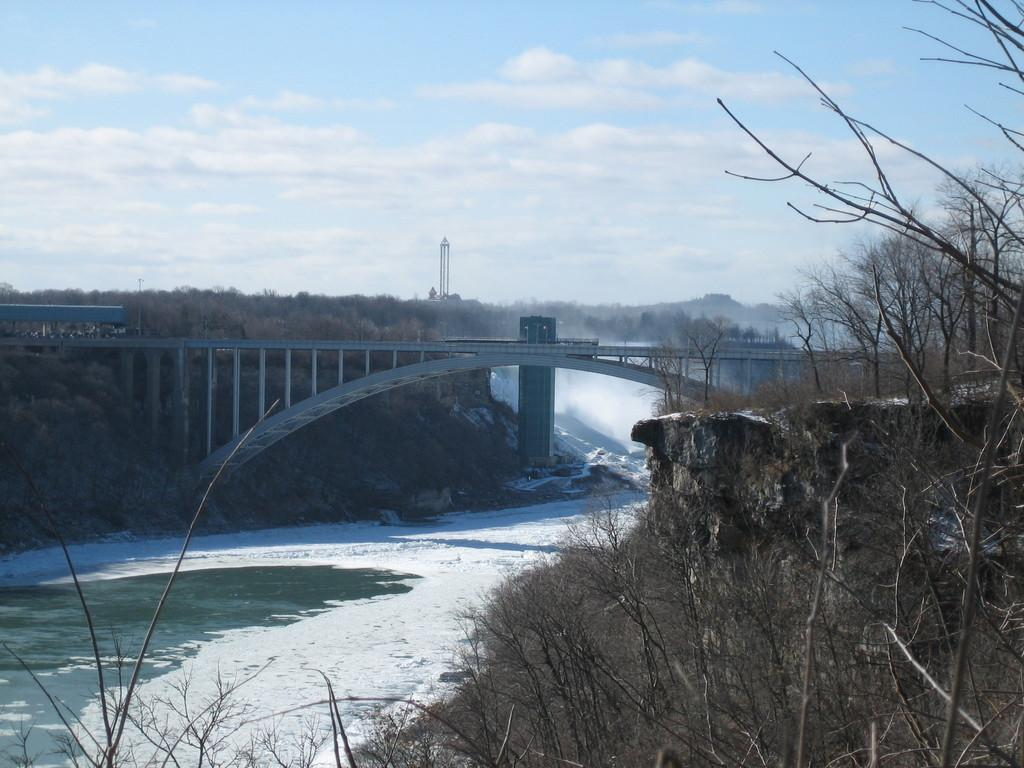What type of structure can be seen in the image? There is a bridge in the image. What natural elements are present in the image? There are trees and water visible in the image. What other man-made structure can be seen in the image? There is a tower in the image. How would you describe the sky in the image? The sky is blue and cloudy in the image. Can you tell me the condition of the nuts in the image? There are no nuts present in the image. How does the flock of birds interact with the bridge in the image? There are no birds or flocks visible in the image. 